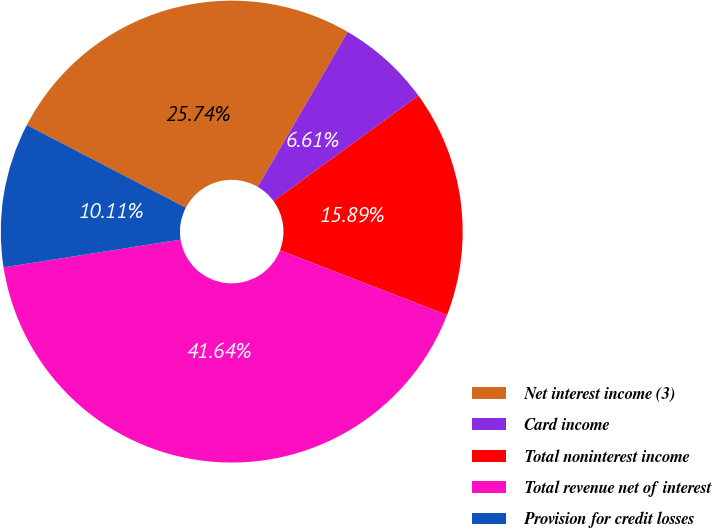<chart> <loc_0><loc_0><loc_500><loc_500><pie_chart><fcel>Net interest income (3)<fcel>Card income<fcel>Total noninterest income<fcel>Total revenue net of interest<fcel>Provision for credit losses<nl><fcel>25.74%<fcel>6.61%<fcel>15.89%<fcel>41.64%<fcel>10.11%<nl></chart> 